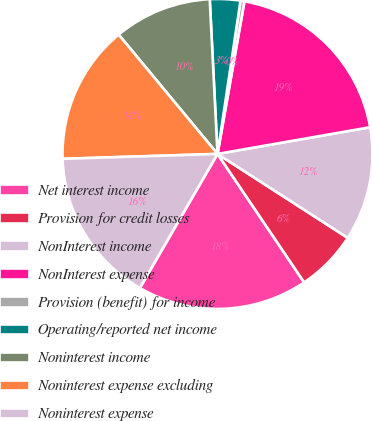<chart> <loc_0><loc_0><loc_500><loc_500><pie_chart><fcel>Net interest income<fcel>Provision for credit losses<fcel>NonInterest income<fcel>NonInterest expense<fcel>Provision (benefit) for income<fcel>Operating/reported net income<fcel>Noninterest income<fcel>Noninterest expense excluding<fcel>Noninterest expense<nl><fcel>17.8%<fcel>6.44%<fcel>11.87%<fcel>19.46%<fcel>0.41%<fcel>3.17%<fcel>10.21%<fcel>14.49%<fcel>16.14%<nl></chart> 